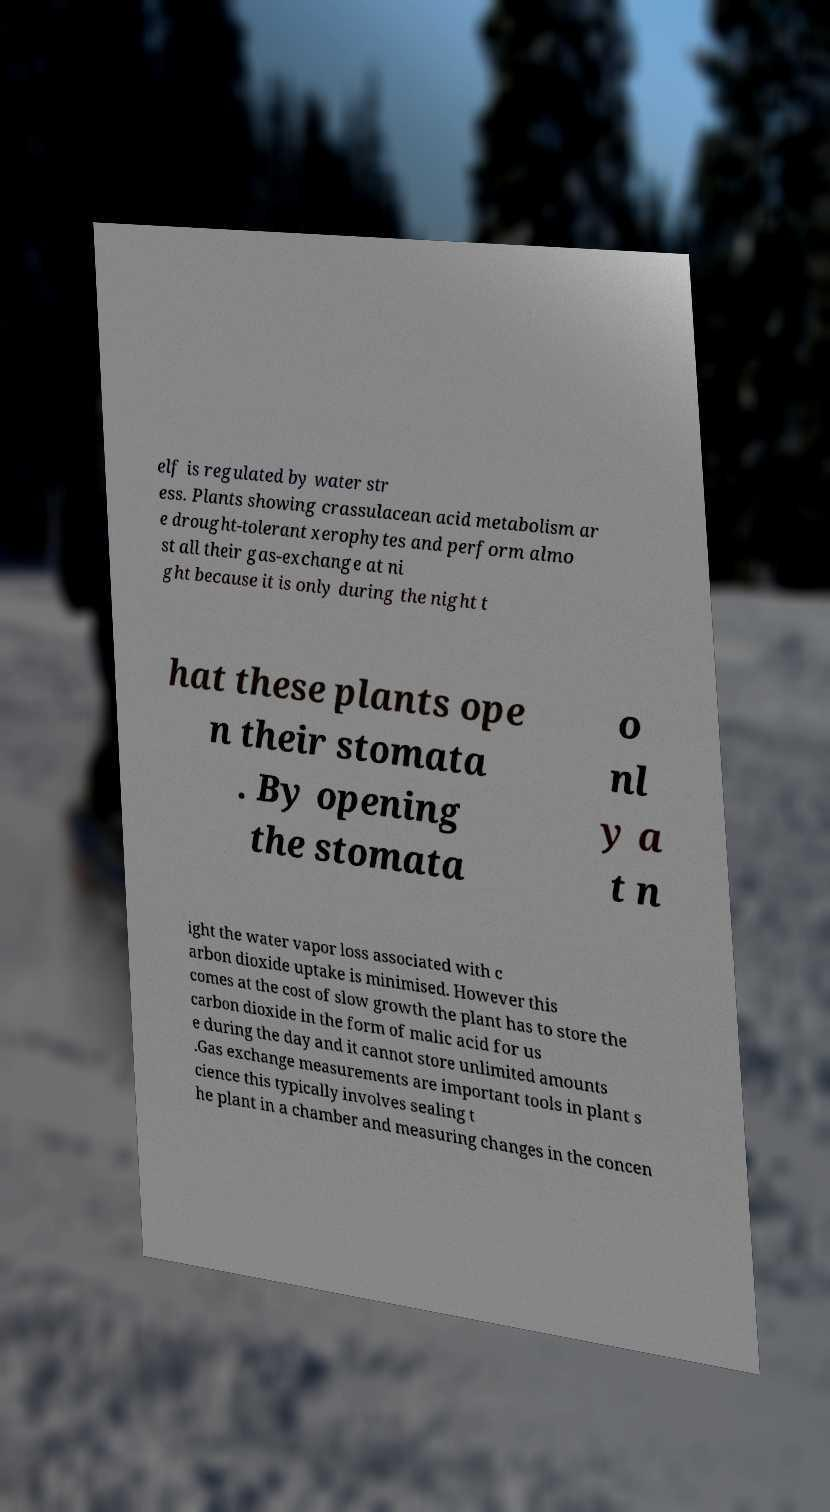Can you accurately transcribe the text from the provided image for me? elf is regulated by water str ess. Plants showing crassulacean acid metabolism ar e drought-tolerant xerophytes and perform almo st all their gas-exchange at ni ght because it is only during the night t hat these plants ope n their stomata . By opening the stomata o nl y a t n ight the water vapor loss associated with c arbon dioxide uptake is minimised. However this comes at the cost of slow growth the plant has to store the carbon dioxide in the form of malic acid for us e during the day and it cannot store unlimited amounts .Gas exchange measurements are important tools in plant s cience this typically involves sealing t he plant in a chamber and measuring changes in the concen 